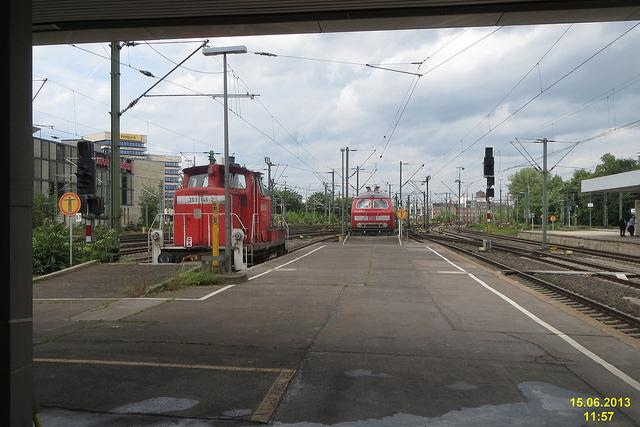How many years back the photograph was taken? eight 